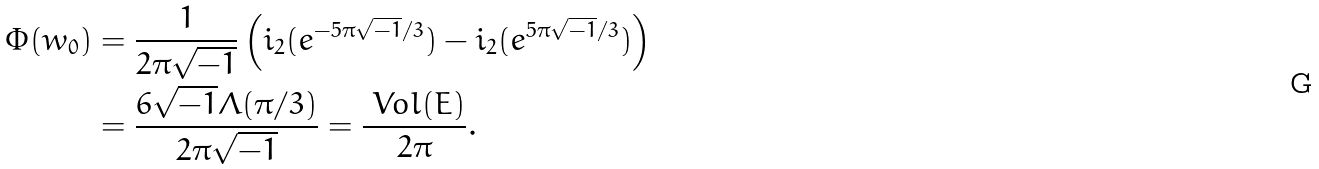Convert formula to latex. <formula><loc_0><loc_0><loc_500><loc_500>\Phi ( w _ { 0 } ) & = \frac { 1 } { 2 \pi \sqrt { - 1 } } \left ( \L i _ { 2 } ( e ^ { - 5 \pi \sqrt { - 1 } / 3 } ) - \L i _ { 2 } ( e ^ { 5 \pi \sqrt { - 1 } / 3 } ) \right ) \\ & = \frac { 6 \sqrt { - 1 } \Lambda ( \pi / 3 ) } { 2 \pi \sqrt { - 1 } } = \frac { \ V o l ( E ) } { 2 \pi } .</formula> 